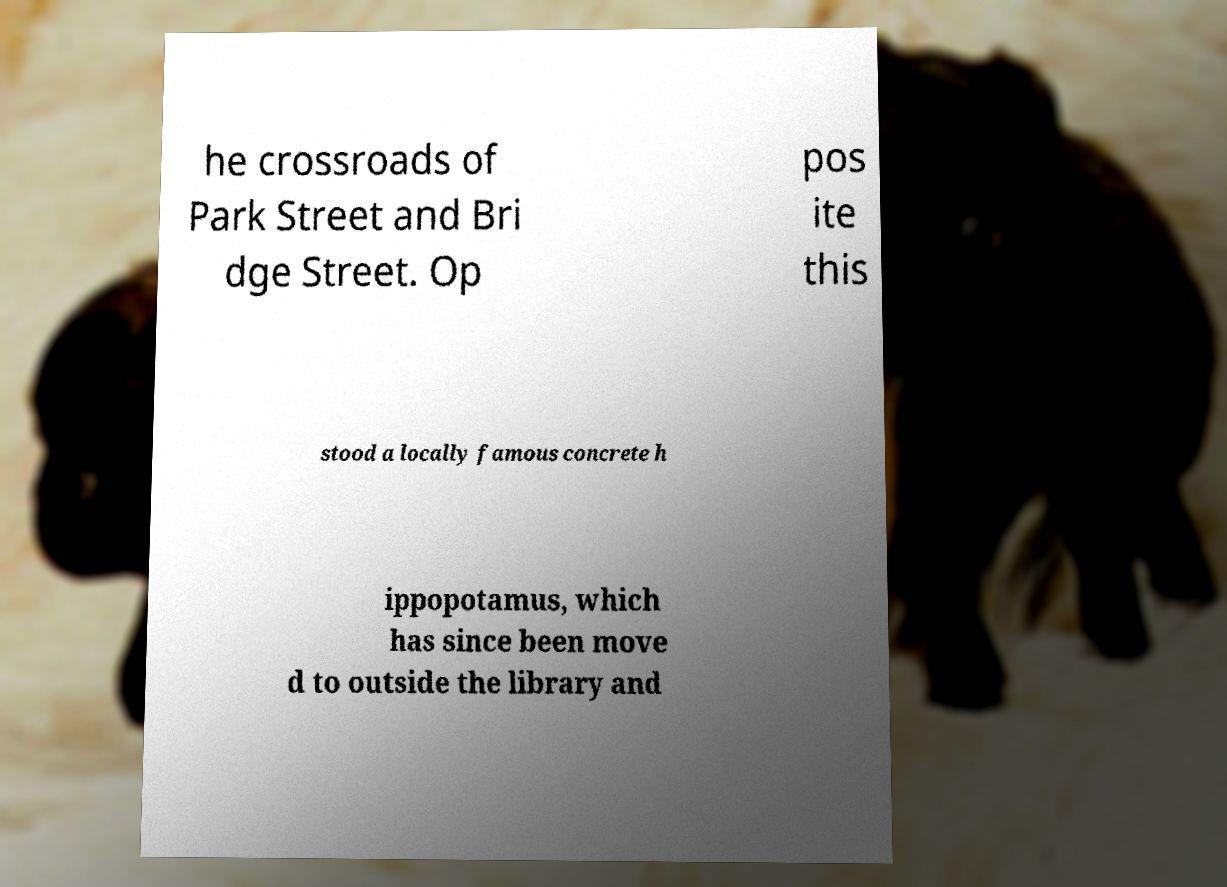What messages or text are displayed in this image? I need them in a readable, typed format. he crossroads of Park Street and Bri dge Street. Op pos ite this stood a locally famous concrete h ippopotamus, which has since been move d to outside the library and 